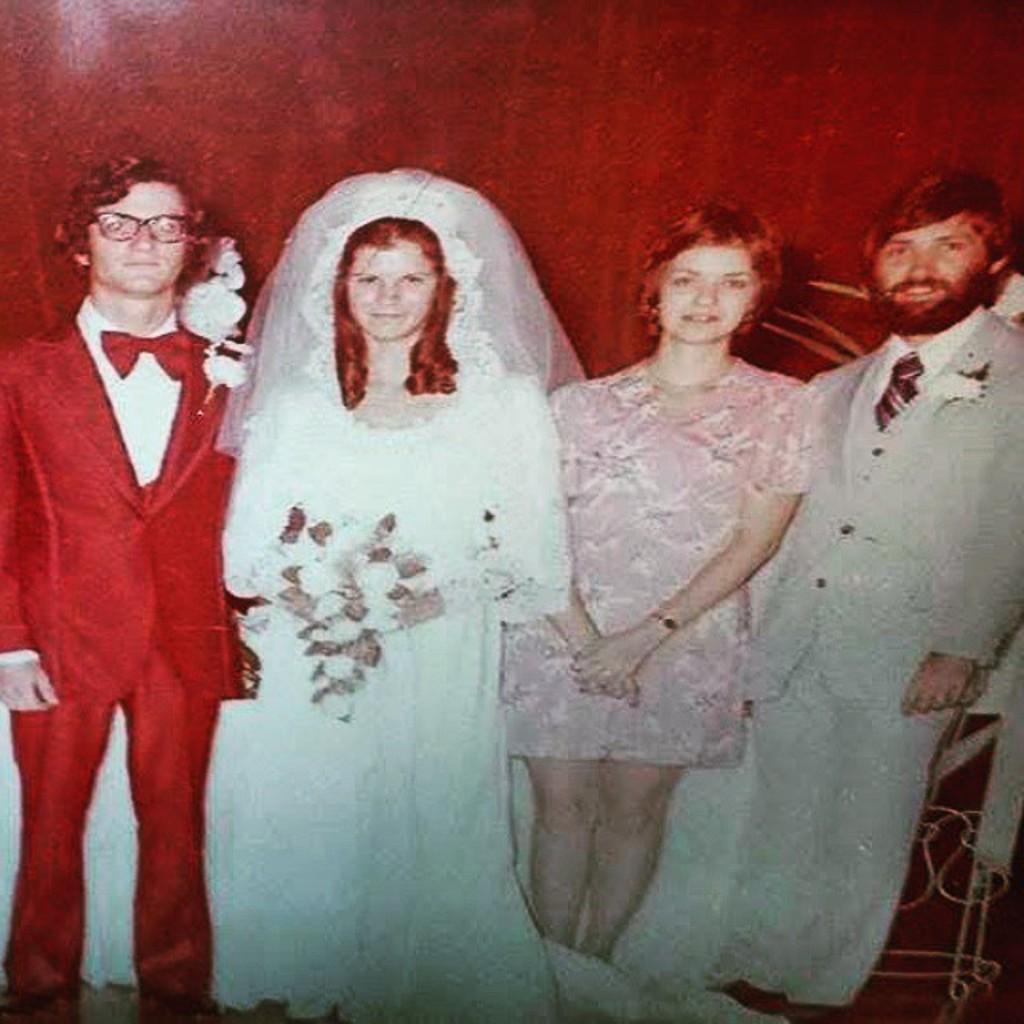In one or two sentences, can you explain what this image depicts? In this image we can see few persons are standing and a woman among them is holding a flower bouquet in her hands. In the background we can see wall and an object on the right side. 